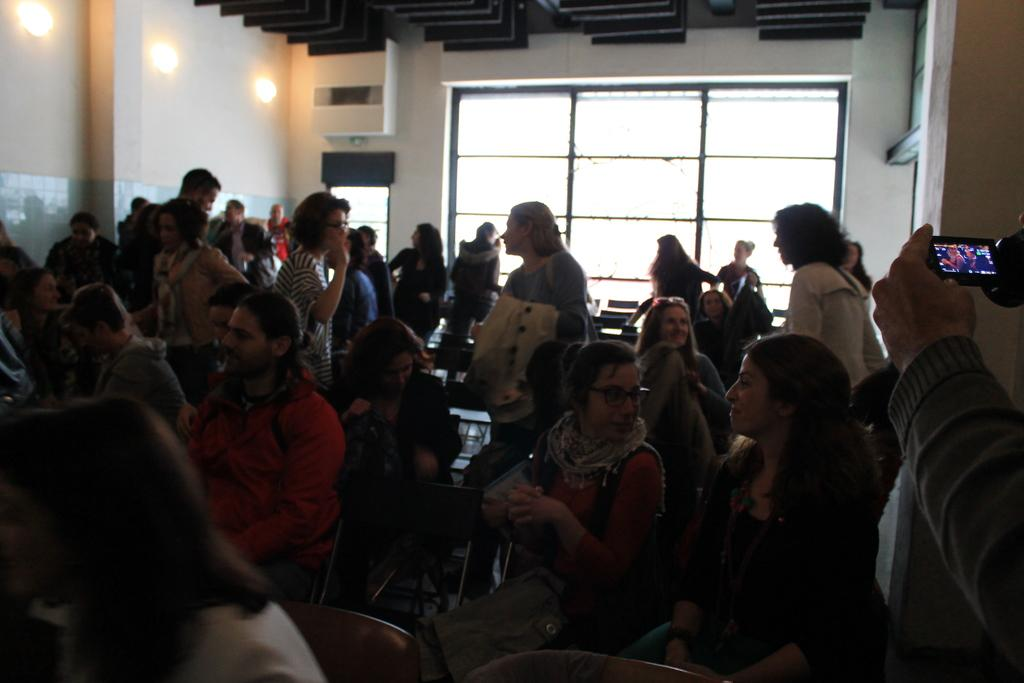What are the persons in the image doing? There are persons sitting and standing in the image. Where are the persons located in the image? The persons are on the floor. What can be seen in the background of the image? There are walls, windows, and electric lights in the background of the image. What type of mouth can be seen on the wall in the image? There is no mouth present on the wall in the image. 